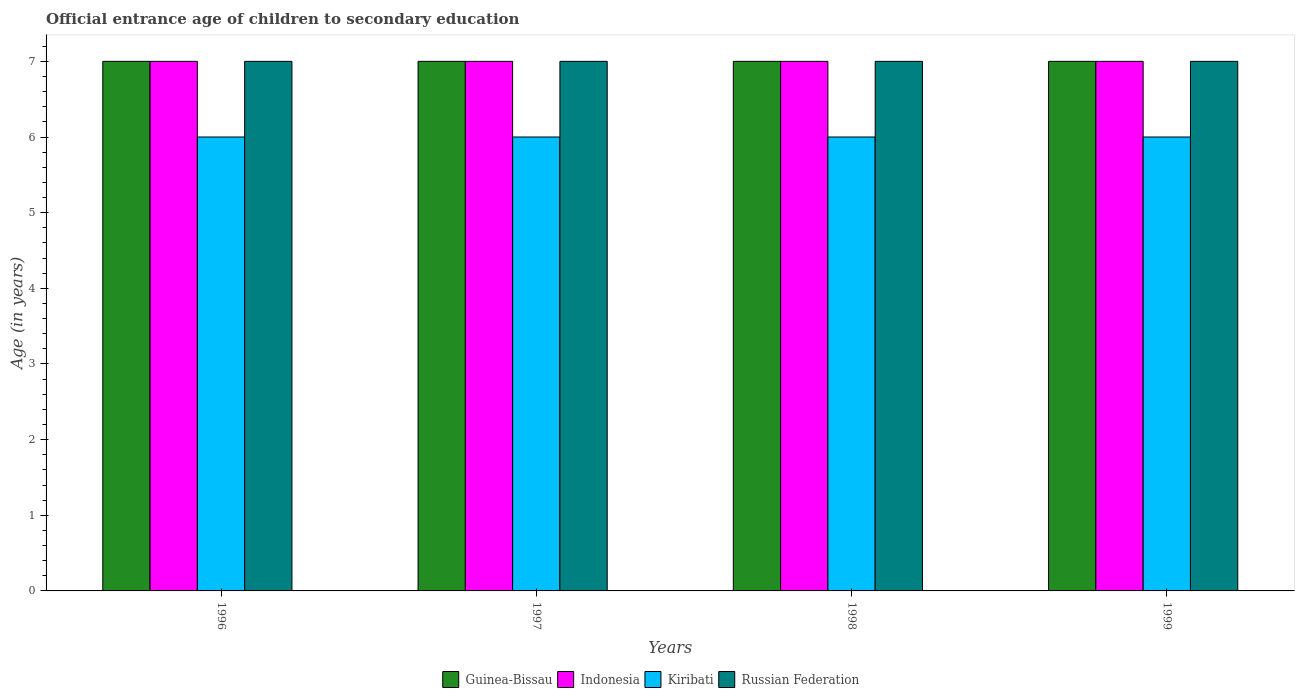Are the number of bars per tick equal to the number of legend labels?
Provide a short and direct response. Yes. How many bars are there on the 2nd tick from the left?
Offer a very short reply. 4. What is the label of the 3rd group of bars from the left?
Keep it short and to the point. 1998. In how many cases, is the number of bars for a given year not equal to the number of legend labels?
Offer a terse response. 0. What is the secondary school starting age of children in Kiribati in 1997?
Provide a short and direct response. 6. Across all years, what is the maximum secondary school starting age of children in Russian Federation?
Ensure brevity in your answer.  7. Across all years, what is the minimum secondary school starting age of children in Indonesia?
Your answer should be very brief. 7. In which year was the secondary school starting age of children in Guinea-Bissau maximum?
Offer a terse response. 1996. In which year was the secondary school starting age of children in Kiribati minimum?
Offer a very short reply. 1996. What is the total secondary school starting age of children in Russian Federation in the graph?
Your answer should be compact. 28. What is the difference between the secondary school starting age of children in Indonesia in 1996 and that in 1997?
Make the answer very short. 0. What is the average secondary school starting age of children in Indonesia per year?
Offer a very short reply. 7. In the year 1999, what is the difference between the secondary school starting age of children in Russian Federation and secondary school starting age of children in Kiribati?
Keep it short and to the point. 1. In how many years, is the secondary school starting age of children in Kiribati greater than 1.4 years?
Give a very brief answer. 4. What is the ratio of the secondary school starting age of children in Indonesia in 1996 to that in 1999?
Offer a terse response. 1. Is the secondary school starting age of children in Kiribati in 1996 less than that in 1998?
Keep it short and to the point. No. Is the difference between the secondary school starting age of children in Russian Federation in 1996 and 1999 greater than the difference between the secondary school starting age of children in Kiribati in 1996 and 1999?
Your answer should be very brief. No. What is the difference between the highest and the second highest secondary school starting age of children in Russian Federation?
Offer a very short reply. 0. In how many years, is the secondary school starting age of children in Indonesia greater than the average secondary school starting age of children in Indonesia taken over all years?
Make the answer very short. 0. Is the sum of the secondary school starting age of children in Russian Federation in 1998 and 1999 greater than the maximum secondary school starting age of children in Guinea-Bissau across all years?
Your response must be concise. Yes. What does the 3rd bar from the left in 1996 represents?
Make the answer very short. Kiribati. What does the 2nd bar from the right in 1996 represents?
Offer a terse response. Kiribati. How many bars are there?
Your answer should be very brief. 16. How many years are there in the graph?
Provide a short and direct response. 4. What is the difference between two consecutive major ticks on the Y-axis?
Your answer should be compact. 1. Are the values on the major ticks of Y-axis written in scientific E-notation?
Offer a terse response. No. Does the graph contain any zero values?
Offer a terse response. No. Does the graph contain grids?
Provide a succinct answer. No. How many legend labels are there?
Provide a short and direct response. 4. What is the title of the graph?
Provide a succinct answer. Official entrance age of children to secondary education. Does "Iceland" appear as one of the legend labels in the graph?
Ensure brevity in your answer.  No. What is the label or title of the Y-axis?
Offer a very short reply. Age (in years). What is the Age (in years) of Guinea-Bissau in 1996?
Provide a succinct answer. 7. What is the Age (in years) of Kiribati in 1996?
Offer a very short reply. 6. What is the Age (in years) of Russian Federation in 1997?
Keep it short and to the point. 7. What is the Age (in years) in Kiribati in 1998?
Your answer should be compact. 6. What is the Age (in years) in Russian Federation in 1998?
Make the answer very short. 7. What is the Age (in years) in Kiribati in 1999?
Offer a terse response. 6. What is the Age (in years) in Russian Federation in 1999?
Offer a very short reply. 7. Across all years, what is the maximum Age (in years) of Guinea-Bissau?
Keep it short and to the point. 7. Across all years, what is the maximum Age (in years) of Indonesia?
Your answer should be compact. 7. Across all years, what is the maximum Age (in years) in Kiribati?
Make the answer very short. 6. Across all years, what is the maximum Age (in years) in Russian Federation?
Provide a short and direct response. 7. Across all years, what is the minimum Age (in years) in Russian Federation?
Your answer should be compact. 7. What is the total Age (in years) in Indonesia in the graph?
Your response must be concise. 28. What is the total Age (in years) of Kiribati in the graph?
Offer a very short reply. 24. What is the difference between the Age (in years) of Guinea-Bissau in 1996 and that in 1997?
Keep it short and to the point. 0. What is the difference between the Age (in years) of Indonesia in 1996 and that in 1997?
Provide a succinct answer. 0. What is the difference between the Age (in years) of Kiribati in 1996 and that in 1997?
Keep it short and to the point. 0. What is the difference between the Age (in years) in Kiribati in 1996 and that in 1998?
Keep it short and to the point. 0. What is the difference between the Age (in years) of Russian Federation in 1996 and that in 1999?
Make the answer very short. 0. What is the difference between the Age (in years) of Indonesia in 1997 and that in 1999?
Provide a short and direct response. 0. What is the difference between the Age (in years) in Indonesia in 1998 and that in 1999?
Keep it short and to the point. 0. What is the difference between the Age (in years) of Kiribati in 1998 and that in 1999?
Give a very brief answer. 0. What is the difference between the Age (in years) in Guinea-Bissau in 1996 and the Age (in years) in Indonesia in 1997?
Make the answer very short. 0. What is the difference between the Age (in years) of Indonesia in 1996 and the Age (in years) of Kiribati in 1997?
Provide a succinct answer. 1. What is the difference between the Age (in years) of Indonesia in 1996 and the Age (in years) of Russian Federation in 1997?
Your answer should be compact. 0. What is the difference between the Age (in years) in Kiribati in 1996 and the Age (in years) in Russian Federation in 1997?
Give a very brief answer. -1. What is the difference between the Age (in years) in Guinea-Bissau in 1996 and the Age (in years) in Indonesia in 1998?
Make the answer very short. 0. What is the difference between the Age (in years) in Guinea-Bissau in 1996 and the Age (in years) in Russian Federation in 1998?
Your answer should be very brief. 0. What is the difference between the Age (in years) in Indonesia in 1996 and the Age (in years) in Kiribati in 1998?
Provide a short and direct response. 1. What is the difference between the Age (in years) of Indonesia in 1996 and the Age (in years) of Russian Federation in 1998?
Your answer should be very brief. 0. What is the difference between the Age (in years) in Kiribati in 1996 and the Age (in years) in Russian Federation in 1998?
Your answer should be compact. -1. What is the difference between the Age (in years) in Guinea-Bissau in 1996 and the Age (in years) in Indonesia in 1999?
Your response must be concise. 0. What is the difference between the Age (in years) of Guinea-Bissau in 1996 and the Age (in years) of Kiribati in 1999?
Your response must be concise. 1. What is the difference between the Age (in years) in Guinea-Bissau in 1997 and the Age (in years) in Kiribati in 1998?
Your response must be concise. 1. What is the difference between the Age (in years) of Guinea-Bissau in 1997 and the Age (in years) of Russian Federation in 1998?
Your answer should be compact. 0. What is the difference between the Age (in years) of Guinea-Bissau in 1997 and the Age (in years) of Indonesia in 1999?
Make the answer very short. 0. What is the difference between the Age (in years) of Guinea-Bissau in 1997 and the Age (in years) of Kiribati in 1999?
Offer a very short reply. 1. What is the difference between the Age (in years) in Guinea-Bissau in 1997 and the Age (in years) in Russian Federation in 1999?
Ensure brevity in your answer.  0. What is the difference between the Age (in years) of Indonesia in 1997 and the Age (in years) of Kiribati in 1999?
Keep it short and to the point. 1. What is the difference between the Age (in years) in Kiribati in 1997 and the Age (in years) in Russian Federation in 1999?
Give a very brief answer. -1. What is the difference between the Age (in years) in Guinea-Bissau in 1998 and the Age (in years) in Indonesia in 1999?
Your response must be concise. 0. What is the difference between the Age (in years) of Kiribati in 1998 and the Age (in years) of Russian Federation in 1999?
Make the answer very short. -1. What is the average Age (in years) in Kiribati per year?
Ensure brevity in your answer.  6. What is the average Age (in years) of Russian Federation per year?
Your response must be concise. 7. In the year 1996, what is the difference between the Age (in years) in Guinea-Bissau and Age (in years) in Indonesia?
Give a very brief answer. 0. In the year 1996, what is the difference between the Age (in years) in Guinea-Bissau and Age (in years) in Kiribati?
Offer a very short reply. 1. In the year 1996, what is the difference between the Age (in years) in Guinea-Bissau and Age (in years) in Russian Federation?
Your answer should be very brief. 0. In the year 1996, what is the difference between the Age (in years) in Indonesia and Age (in years) in Kiribati?
Offer a terse response. 1. In the year 1996, what is the difference between the Age (in years) in Indonesia and Age (in years) in Russian Federation?
Your answer should be very brief. 0. In the year 1996, what is the difference between the Age (in years) in Kiribati and Age (in years) in Russian Federation?
Provide a succinct answer. -1. In the year 1997, what is the difference between the Age (in years) in Guinea-Bissau and Age (in years) in Kiribati?
Keep it short and to the point. 1. In the year 1997, what is the difference between the Age (in years) in Kiribati and Age (in years) in Russian Federation?
Provide a short and direct response. -1. In the year 1998, what is the difference between the Age (in years) of Guinea-Bissau and Age (in years) of Indonesia?
Your response must be concise. 0. In the year 1998, what is the difference between the Age (in years) of Guinea-Bissau and Age (in years) of Kiribati?
Your answer should be compact. 1. In the year 1999, what is the difference between the Age (in years) in Guinea-Bissau and Age (in years) in Indonesia?
Ensure brevity in your answer.  0. In the year 1999, what is the difference between the Age (in years) of Guinea-Bissau and Age (in years) of Kiribati?
Offer a terse response. 1. In the year 1999, what is the difference between the Age (in years) of Kiribati and Age (in years) of Russian Federation?
Your response must be concise. -1. What is the ratio of the Age (in years) in Indonesia in 1996 to that in 1998?
Provide a succinct answer. 1. What is the ratio of the Age (in years) in Kiribati in 1996 to that in 1998?
Your answer should be very brief. 1. What is the ratio of the Age (in years) of Russian Federation in 1996 to that in 1998?
Your answer should be compact. 1. What is the ratio of the Age (in years) in Guinea-Bissau in 1996 to that in 1999?
Your answer should be very brief. 1. What is the ratio of the Age (in years) of Indonesia in 1996 to that in 1999?
Offer a very short reply. 1. What is the ratio of the Age (in years) in Kiribati in 1996 to that in 1999?
Ensure brevity in your answer.  1. What is the ratio of the Age (in years) of Russian Federation in 1997 to that in 1998?
Keep it short and to the point. 1. What is the ratio of the Age (in years) in Guinea-Bissau in 1997 to that in 1999?
Give a very brief answer. 1. What is the ratio of the Age (in years) of Indonesia in 1997 to that in 1999?
Offer a very short reply. 1. What is the ratio of the Age (in years) of Kiribati in 1997 to that in 1999?
Offer a very short reply. 1. What is the ratio of the Age (in years) of Indonesia in 1998 to that in 1999?
Offer a very short reply. 1. What is the ratio of the Age (in years) of Kiribati in 1998 to that in 1999?
Offer a very short reply. 1. What is the ratio of the Age (in years) of Russian Federation in 1998 to that in 1999?
Offer a very short reply. 1. What is the difference between the highest and the second highest Age (in years) of Kiribati?
Provide a succinct answer. 0. What is the difference between the highest and the second highest Age (in years) of Russian Federation?
Give a very brief answer. 0. What is the difference between the highest and the lowest Age (in years) in Guinea-Bissau?
Your answer should be very brief. 0. What is the difference between the highest and the lowest Age (in years) of Kiribati?
Your answer should be very brief. 0. 